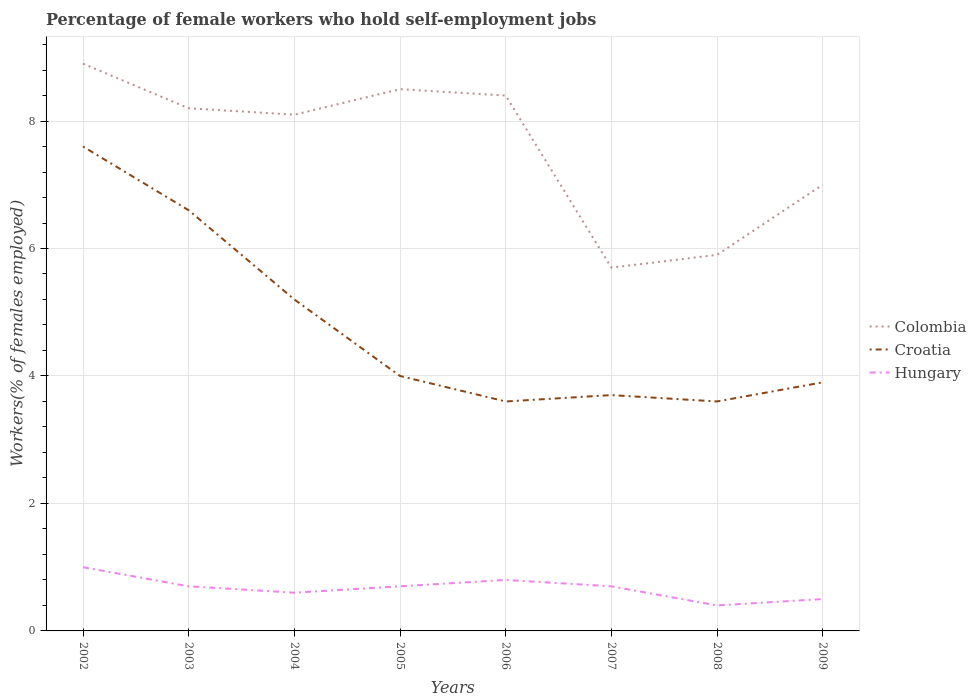How many different coloured lines are there?
Your answer should be compact. 3. Across all years, what is the maximum percentage of self-employed female workers in Hungary?
Your answer should be very brief. 0.4. What is the total percentage of self-employed female workers in Croatia in the graph?
Ensure brevity in your answer.  0.4. What is the difference between the highest and the second highest percentage of self-employed female workers in Colombia?
Offer a very short reply. 3.2. Is the percentage of self-employed female workers in Colombia strictly greater than the percentage of self-employed female workers in Hungary over the years?
Offer a very short reply. No. How many years are there in the graph?
Provide a succinct answer. 8. What is the difference between two consecutive major ticks on the Y-axis?
Give a very brief answer. 2. Are the values on the major ticks of Y-axis written in scientific E-notation?
Give a very brief answer. No. Does the graph contain any zero values?
Your answer should be very brief. No. Where does the legend appear in the graph?
Ensure brevity in your answer.  Center right. How many legend labels are there?
Keep it short and to the point. 3. How are the legend labels stacked?
Provide a succinct answer. Vertical. What is the title of the graph?
Keep it short and to the point. Percentage of female workers who hold self-employment jobs. What is the label or title of the X-axis?
Your answer should be compact. Years. What is the label or title of the Y-axis?
Give a very brief answer. Workers(% of females employed). What is the Workers(% of females employed) in Colombia in 2002?
Provide a short and direct response. 8.9. What is the Workers(% of females employed) in Croatia in 2002?
Make the answer very short. 7.6. What is the Workers(% of females employed) in Hungary in 2002?
Your answer should be compact. 1. What is the Workers(% of females employed) in Colombia in 2003?
Your answer should be compact. 8.2. What is the Workers(% of females employed) in Croatia in 2003?
Make the answer very short. 6.6. What is the Workers(% of females employed) of Hungary in 2003?
Ensure brevity in your answer.  0.7. What is the Workers(% of females employed) of Colombia in 2004?
Your response must be concise. 8.1. What is the Workers(% of females employed) of Croatia in 2004?
Give a very brief answer. 5.2. What is the Workers(% of females employed) of Hungary in 2004?
Your response must be concise. 0.6. What is the Workers(% of females employed) in Colombia in 2005?
Keep it short and to the point. 8.5. What is the Workers(% of females employed) in Hungary in 2005?
Offer a very short reply. 0.7. What is the Workers(% of females employed) in Colombia in 2006?
Keep it short and to the point. 8.4. What is the Workers(% of females employed) in Croatia in 2006?
Keep it short and to the point. 3.6. What is the Workers(% of females employed) in Hungary in 2006?
Provide a short and direct response. 0.8. What is the Workers(% of females employed) of Colombia in 2007?
Provide a succinct answer. 5.7. What is the Workers(% of females employed) in Croatia in 2007?
Provide a succinct answer. 3.7. What is the Workers(% of females employed) in Hungary in 2007?
Your answer should be very brief. 0.7. What is the Workers(% of females employed) in Colombia in 2008?
Provide a short and direct response. 5.9. What is the Workers(% of females employed) in Croatia in 2008?
Your answer should be compact. 3.6. What is the Workers(% of females employed) in Hungary in 2008?
Give a very brief answer. 0.4. What is the Workers(% of females employed) of Croatia in 2009?
Ensure brevity in your answer.  3.9. Across all years, what is the maximum Workers(% of females employed) of Colombia?
Provide a succinct answer. 8.9. Across all years, what is the maximum Workers(% of females employed) in Croatia?
Ensure brevity in your answer.  7.6. Across all years, what is the minimum Workers(% of females employed) in Colombia?
Your response must be concise. 5.7. Across all years, what is the minimum Workers(% of females employed) of Croatia?
Your response must be concise. 3.6. Across all years, what is the minimum Workers(% of females employed) in Hungary?
Provide a succinct answer. 0.4. What is the total Workers(% of females employed) in Colombia in the graph?
Keep it short and to the point. 60.7. What is the total Workers(% of females employed) of Croatia in the graph?
Offer a terse response. 38.2. What is the total Workers(% of females employed) of Hungary in the graph?
Ensure brevity in your answer.  5.4. What is the difference between the Workers(% of females employed) in Colombia in 2002 and that in 2003?
Your answer should be very brief. 0.7. What is the difference between the Workers(% of females employed) in Croatia in 2002 and that in 2003?
Keep it short and to the point. 1. What is the difference between the Workers(% of females employed) in Hungary in 2002 and that in 2003?
Your answer should be compact. 0.3. What is the difference between the Workers(% of females employed) in Colombia in 2002 and that in 2004?
Provide a short and direct response. 0.8. What is the difference between the Workers(% of females employed) of Colombia in 2002 and that in 2005?
Offer a terse response. 0.4. What is the difference between the Workers(% of females employed) of Colombia in 2002 and that in 2006?
Your answer should be compact. 0.5. What is the difference between the Workers(% of females employed) in Croatia in 2002 and that in 2006?
Your answer should be compact. 4. What is the difference between the Workers(% of females employed) of Hungary in 2002 and that in 2006?
Provide a short and direct response. 0.2. What is the difference between the Workers(% of females employed) in Colombia in 2002 and that in 2007?
Give a very brief answer. 3.2. What is the difference between the Workers(% of females employed) of Hungary in 2002 and that in 2009?
Offer a terse response. 0.5. What is the difference between the Workers(% of females employed) in Colombia in 2003 and that in 2007?
Offer a terse response. 2.5. What is the difference between the Workers(% of females employed) of Hungary in 2003 and that in 2007?
Make the answer very short. 0. What is the difference between the Workers(% of females employed) in Colombia in 2003 and that in 2008?
Keep it short and to the point. 2.3. What is the difference between the Workers(% of females employed) of Hungary in 2003 and that in 2009?
Ensure brevity in your answer.  0.2. What is the difference between the Workers(% of females employed) in Colombia in 2004 and that in 2005?
Make the answer very short. -0.4. What is the difference between the Workers(% of females employed) in Croatia in 2004 and that in 2005?
Offer a terse response. 1.2. What is the difference between the Workers(% of females employed) of Hungary in 2004 and that in 2005?
Ensure brevity in your answer.  -0.1. What is the difference between the Workers(% of females employed) of Colombia in 2004 and that in 2006?
Provide a succinct answer. -0.3. What is the difference between the Workers(% of females employed) of Colombia in 2004 and that in 2007?
Ensure brevity in your answer.  2.4. What is the difference between the Workers(% of females employed) of Hungary in 2004 and that in 2008?
Offer a terse response. 0.2. What is the difference between the Workers(% of females employed) in Croatia in 2005 and that in 2007?
Give a very brief answer. 0.3. What is the difference between the Workers(% of females employed) of Hungary in 2005 and that in 2007?
Offer a very short reply. 0. What is the difference between the Workers(% of females employed) in Croatia in 2005 and that in 2008?
Ensure brevity in your answer.  0.4. What is the difference between the Workers(% of females employed) in Croatia in 2005 and that in 2009?
Provide a short and direct response. 0.1. What is the difference between the Workers(% of females employed) in Hungary in 2005 and that in 2009?
Your answer should be very brief. 0.2. What is the difference between the Workers(% of females employed) of Colombia in 2006 and that in 2007?
Make the answer very short. 2.7. What is the difference between the Workers(% of females employed) in Croatia in 2006 and that in 2007?
Your answer should be compact. -0.1. What is the difference between the Workers(% of females employed) in Hungary in 2006 and that in 2007?
Provide a short and direct response. 0.1. What is the difference between the Workers(% of females employed) of Colombia in 2006 and that in 2008?
Your response must be concise. 2.5. What is the difference between the Workers(% of females employed) of Croatia in 2006 and that in 2008?
Your answer should be very brief. 0. What is the difference between the Workers(% of females employed) in Hungary in 2006 and that in 2008?
Offer a terse response. 0.4. What is the difference between the Workers(% of females employed) in Croatia in 2006 and that in 2009?
Offer a terse response. -0.3. What is the difference between the Workers(% of females employed) in Colombia in 2007 and that in 2009?
Give a very brief answer. -1.3. What is the difference between the Workers(% of females employed) of Croatia in 2007 and that in 2009?
Ensure brevity in your answer.  -0.2. What is the difference between the Workers(% of females employed) of Colombia in 2002 and the Workers(% of females employed) of Hungary in 2003?
Keep it short and to the point. 8.2. What is the difference between the Workers(% of females employed) of Colombia in 2002 and the Workers(% of females employed) of Croatia in 2004?
Ensure brevity in your answer.  3.7. What is the difference between the Workers(% of females employed) in Croatia in 2002 and the Workers(% of females employed) in Hungary in 2004?
Offer a terse response. 7. What is the difference between the Workers(% of females employed) in Colombia in 2002 and the Workers(% of females employed) in Hungary in 2005?
Ensure brevity in your answer.  8.2. What is the difference between the Workers(% of females employed) in Colombia in 2002 and the Workers(% of females employed) in Hungary in 2006?
Provide a short and direct response. 8.1. What is the difference between the Workers(% of females employed) in Colombia in 2002 and the Workers(% of females employed) in Croatia in 2007?
Give a very brief answer. 5.2. What is the difference between the Workers(% of females employed) in Colombia in 2002 and the Workers(% of females employed) in Hungary in 2007?
Provide a short and direct response. 8.2. What is the difference between the Workers(% of females employed) in Croatia in 2003 and the Workers(% of females employed) in Hungary in 2004?
Your answer should be compact. 6. What is the difference between the Workers(% of females employed) of Croatia in 2003 and the Workers(% of females employed) of Hungary in 2005?
Your answer should be compact. 5.9. What is the difference between the Workers(% of females employed) in Colombia in 2003 and the Workers(% of females employed) in Croatia in 2006?
Your answer should be very brief. 4.6. What is the difference between the Workers(% of females employed) of Colombia in 2003 and the Workers(% of females employed) of Hungary in 2006?
Your answer should be very brief. 7.4. What is the difference between the Workers(% of females employed) in Colombia in 2003 and the Workers(% of females employed) in Croatia in 2007?
Your answer should be very brief. 4.5. What is the difference between the Workers(% of females employed) of Colombia in 2003 and the Workers(% of females employed) of Croatia in 2009?
Make the answer very short. 4.3. What is the difference between the Workers(% of females employed) in Colombia in 2003 and the Workers(% of females employed) in Hungary in 2009?
Your answer should be very brief. 7.7. What is the difference between the Workers(% of females employed) of Croatia in 2003 and the Workers(% of females employed) of Hungary in 2009?
Give a very brief answer. 6.1. What is the difference between the Workers(% of females employed) of Colombia in 2004 and the Workers(% of females employed) of Croatia in 2005?
Ensure brevity in your answer.  4.1. What is the difference between the Workers(% of females employed) of Colombia in 2004 and the Workers(% of females employed) of Hungary in 2005?
Your answer should be compact. 7.4. What is the difference between the Workers(% of females employed) of Croatia in 2004 and the Workers(% of females employed) of Hungary in 2005?
Ensure brevity in your answer.  4.5. What is the difference between the Workers(% of females employed) of Colombia in 2004 and the Workers(% of females employed) of Hungary in 2006?
Provide a short and direct response. 7.3. What is the difference between the Workers(% of females employed) in Croatia in 2004 and the Workers(% of females employed) in Hungary in 2006?
Keep it short and to the point. 4.4. What is the difference between the Workers(% of females employed) in Croatia in 2004 and the Workers(% of females employed) in Hungary in 2007?
Provide a succinct answer. 4.5. What is the difference between the Workers(% of females employed) in Colombia in 2004 and the Workers(% of females employed) in Croatia in 2008?
Ensure brevity in your answer.  4.5. What is the difference between the Workers(% of females employed) of Croatia in 2004 and the Workers(% of females employed) of Hungary in 2009?
Give a very brief answer. 4.7. What is the difference between the Workers(% of females employed) in Colombia in 2005 and the Workers(% of females employed) in Croatia in 2006?
Provide a short and direct response. 4.9. What is the difference between the Workers(% of females employed) of Croatia in 2005 and the Workers(% of females employed) of Hungary in 2006?
Keep it short and to the point. 3.2. What is the difference between the Workers(% of females employed) of Croatia in 2005 and the Workers(% of females employed) of Hungary in 2008?
Your answer should be compact. 3.6. What is the difference between the Workers(% of females employed) of Colombia in 2005 and the Workers(% of females employed) of Hungary in 2009?
Keep it short and to the point. 8. What is the difference between the Workers(% of females employed) of Croatia in 2005 and the Workers(% of females employed) of Hungary in 2009?
Offer a terse response. 3.5. What is the difference between the Workers(% of females employed) of Colombia in 2006 and the Workers(% of females employed) of Hungary in 2007?
Ensure brevity in your answer.  7.7. What is the difference between the Workers(% of females employed) of Croatia in 2006 and the Workers(% of females employed) of Hungary in 2007?
Offer a terse response. 2.9. What is the difference between the Workers(% of females employed) in Colombia in 2006 and the Workers(% of females employed) in Croatia in 2008?
Make the answer very short. 4.8. What is the difference between the Workers(% of females employed) of Colombia in 2006 and the Workers(% of females employed) of Croatia in 2009?
Provide a short and direct response. 4.5. What is the difference between the Workers(% of females employed) of Colombia in 2007 and the Workers(% of females employed) of Croatia in 2008?
Provide a succinct answer. 2.1. What is the difference between the Workers(% of females employed) of Croatia in 2007 and the Workers(% of females employed) of Hungary in 2008?
Give a very brief answer. 3.3. What is the difference between the Workers(% of females employed) in Colombia in 2007 and the Workers(% of females employed) in Hungary in 2009?
Give a very brief answer. 5.2. What is the difference between the Workers(% of females employed) of Colombia in 2008 and the Workers(% of females employed) of Croatia in 2009?
Your answer should be compact. 2. What is the difference between the Workers(% of females employed) in Croatia in 2008 and the Workers(% of females employed) in Hungary in 2009?
Make the answer very short. 3.1. What is the average Workers(% of females employed) in Colombia per year?
Give a very brief answer. 7.59. What is the average Workers(% of females employed) of Croatia per year?
Your response must be concise. 4.78. What is the average Workers(% of females employed) in Hungary per year?
Provide a succinct answer. 0.68. In the year 2002, what is the difference between the Workers(% of females employed) in Colombia and Workers(% of females employed) in Hungary?
Your response must be concise. 7.9. In the year 2002, what is the difference between the Workers(% of females employed) of Croatia and Workers(% of females employed) of Hungary?
Provide a short and direct response. 6.6. In the year 2003, what is the difference between the Workers(% of females employed) in Colombia and Workers(% of females employed) in Hungary?
Provide a succinct answer. 7.5. In the year 2004, what is the difference between the Workers(% of females employed) of Colombia and Workers(% of females employed) of Croatia?
Your answer should be compact. 2.9. In the year 2004, what is the difference between the Workers(% of females employed) of Colombia and Workers(% of females employed) of Hungary?
Keep it short and to the point. 7.5. In the year 2005, what is the difference between the Workers(% of females employed) of Colombia and Workers(% of females employed) of Croatia?
Provide a short and direct response. 4.5. In the year 2005, what is the difference between the Workers(% of females employed) in Croatia and Workers(% of females employed) in Hungary?
Keep it short and to the point. 3.3. In the year 2006, what is the difference between the Workers(% of females employed) of Colombia and Workers(% of females employed) of Croatia?
Give a very brief answer. 4.8. In the year 2006, what is the difference between the Workers(% of females employed) of Colombia and Workers(% of females employed) of Hungary?
Provide a short and direct response. 7.6. In the year 2006, what is the difference between the Workers(% of females employed) of Croatia and Workers(% of females employed) of Hungary?
Offer a terse response. 2.8. In the year 2007, what is the difference between the Workers(% of females employed) of Colombia and Workers(% of females employed) of Croatia?
Provide a succinct answer. 2. In the year 2007, what is the difference between the Workers(% of females employed) of Croatia and Workers(% of females employed) of Hungary?
Make the answer very short. 3. In the year 2008, what is the difference between the Workers(% of females employed) of Colombia and Workers(% of females employed) of Croatia?
Make the answer very short. 2.3. In the year 2008, what is the difference between the Workers(% of females employed) in Colombia and Workers(% of females employed) in Hungary?
Provide a short and direct response. 5.5. In the year 2009, what is the difference between the Workers(% of females employed) in Colombia and Workers(% of females employed) in Hungary?
Offer a terse response. 6.5. In the year 2009, what is the difference between the Workers(% of females employed) of Croatia and Workers(% of females employed) of Hungary?
Give a very brief answer. 3.4. What is the ratio of the Workers(% of females employed) in Colombia in 2002 to that in 2003?
Your response must be concise. 1.09. What is the ratio of the Workers(% of females employed) in Croatia in 2002 to that in 2003?
Your answer should be very brief. 1.15. What is the ratio of the Workers(% of females employed) in Hungary in 2002 to that in 2003?
Your response must be concise. 1.43. What is the ratio of the Workers(% of females employed) in Colombia in 2002 to that in 2004?
Your answer should be compact. 1.1. What is the ratio of the Workers(% of females employed) of Croatia in 2002 to that in 2004?
Your answer should be very brief. 1.46. What is the ratio of the Workers(% of females employed) of Hungary in 2002 to that in 2004?
Give a very brief answer. 1.67. What is the ratio of the Workers(% of females employed) of Colombia in 2002 to that in 2005?
Give a very brief answer. 1.05. What is the ratio of the Workers(% of females employed) in Croatia in 2002 to that in 2005?
Your answer should be very brief. 1.9. What is the ratio of the Workers(% of females employed) of Hungary in 2002 to that in 2005?
Your answer should be compact. 1.43. What is the ratio of the Workers(% of females employed) in Colombia in 2002 to that in 2006?
Provide a short and direct response. 1.06. What is the ratio of the Workers(% of females employed) of Croatia in 2002 to that in 2006?
Offer a very short reply. 2.11. What is the ratio of the Workers(% of females employed) in Hungary in 2002 to that in 2006?
Your response must be concise. 1.25. What is the ratio of the Workers(% of females employed) of Colombia in 2002 to that in 2007?
Give a very brief answer. 1.56. What is the ratio of the Workers(% of females employed) of Croatia in 2002 to that in 2007?
Your response must be concise. 2.05. What is the ratio of the Workers(% of females employed) in Hungary in 2002 to that in 2007?
Give a very brief answer. 1.43. What is the ratio of the Workers(% of females employed) in Colombia in 2002 to that in 2008?
Ensure brevity in your answer.  1.51. What is the ratio of the Workers(% of females employed) in Croatia in 2002 to that in 2008?
Keep it short and to the point. 2.11. What is the ratio of the Workers(% of females employed) in Hungary in 2002 to that in 2008?
Give a very brief answer. 2.5. What is the ratio of the Workers(% of females employed) in Colombia in 2002 to that in 2009?
Keep it short and to the point. 1.27. What is the ratio of the Workers(% of females employed) of Croatia in 2002 to that in 2009?
Your response must be concise. 1.95. What is the ratio of the Workers(% of females employed) of Hungary in 2002 to that in 2009?
Make the answer very short. 2. What is the ratio of the Workers(% of females employed) of Colombia in 2003 to that in 2004?
Give a very brief answer. 1.01. What is the ratio of the Workers(% of females employed) in Croatia in 2003 to that in 2004?
Your answer should be compact. 1.27. What is the ratio of the Workers(% of females employed) of Colombia in 2003 to that in 2005?
Offer a terse response. 0.96. What is the ratio of the Workers(% of females employed) in Croatia in 2003 to that in 2005?
Your answer should be very brief. 1.65. What is the ratio of the Workers(% of females employed) of Hungary in 2003 to that in 2005?
Offer a terse response. 1. What is the ratio of the Workers(% of females employed) of Colombia in 2003 to that in 2006?
Provide a short and direct response. 0.98. What is the ratio of the Workers(% of females employed) of Croatia in 2003 to that in 2006?
Ensure brevity in your answer.  1.83. What is the ratio of the Workers(% of females employed) in Hungary in 2003 to that in 2006?
Your response must be concise. 0.88. What is the ratio of the Workers(% of females employed) in Colombia in 2003 to that in 2007?
Make the answer very short. 1.44. What is the ratio of the Workers(% of females employed) of Croatia in 2003 to that in 2007?
Offer a terse response. 1.78. What is the ratio of the Workers(% of females employed) in Colombia in 2003 to that in 2008?
Offer a very short reply. 1.39. What is the ratio of the Workers(% of females employed) in Croatia in 2003 to that in 2008?
Your response must be concise. 1.83. What is the ratio of the Workers(% of females employed) of Colombia in 2003 to that in 2009?
Your response must be concise. 1.17. What is the ratio of the Workers(% of females employed) in Croatia in 2003 to that in 2009?
Keep it short and to the point. 1.69. What is the ratio of the Workers(% of females employed) of Colombia in 2004 to that in 2005?
Your answer should be compact. 0.95. What is the ratio of the Workers(% of females employed) of Croatia in 2004 to that in 2006?
Give a very brief answer. 1.44. What is the ratio of the Workers(% of females employed) of Hungary in 2004 to that in 2006?
Your answer should be very brief. 0.75. What is the ratio of the Workers(% of females employed) in Colombia in 2004 to that in 2007?
Offer a terse response. 1.42. What is the ratio of the Workers(% of females employed) of Croatia in 2004 to that in 2007?
Provide a succinct answer. 1.41. What is the ratio of the Workers(% of females employed) of Colombia in 2004 to that in 2008?
Ensure brevity in your answer.  1.37. What is the ratio of the Workers(% of females employed) of Croatia in 2004 to that in 2008?
Give a very brief answer. 1.44. What is the ratio of the Workers(% of females employed) in Colombia in 2004 to that in 2009?
Provide a short and direct response. 1.16. What is the ratio of the Workers(% of females employed) of Colombia in 2005 to that in 2006?
Offer a very short reply. 1.01. What is the ratio of the Workers(% of females employed) in Croatia in 2005 to that in 2006?
Offer a very short reply. 1.11. What is the ratio of the Workers(% of females employed) in Hungary in 2005 to that in 2006?
Make the answer very short. 0.88. What is the ratio of the Workers(% of females employed) in Colombia in 2005 to that in 2007?
Your response must be concise. 1.49. What is the ratio of the Workers(% of females employed) of Croatia in 2005 to that in 2007?
Ensure brevity in your answer.  1.08. What is the ratio of the Workers(% of females employed) in Colombia in 2005 to that in 2008?
Your response must be concise. 1.44. What is the ratio of the Workers(% of females employed) of Hungary in 2005 to that in 2008?
Provide a short and direct response. 1.75. What is the ratio of the Workers(% of females employed) in Colombia in 2005 to that in 2009?
Your answer should be very brief. 1.21. What is the ratio of the Workers(% of females employed) of Croatia in 2005 to that in 2009?
Provide a succinct answer. 1.03. What is the ratio of the Workers(% of females employed) in Colombia in 2006 to that in 2007?
Provide a succinct answer. 1.47. What is the ratio of the Workers(% of females employed) in Croatia in 2006 to that in 2007?
Offer a very short reply. 0.97. What is the ratio of the Workers(% of females employed) of Colombia in 2006 to that in 2008?
Keep it short and to the point. 1.42. What is the ratio of the Workers(% of females employed) in Hungary in 2006 to that in 2008?
Ensure brevity in your answer.  2. What is the ratio of the Workers(% of females employed) of Colombia in 2006 to that in 2009?
Make the answer very short. 1.2. What is the ratio of the Workers(% of females employed) of Croatia in 2006 to that in 2009?
Make the answer very short. 0.92. What is the ratio of the Workers(% of females employed) in Colombia in 2007 to that in 2008?
Provide a succinct answer. 0.97. What is the ratio of the Workers(% of females employed) in Croatia in 2007 to that in 2008?
Offer a very short reply. 1.03. What is the ratio of the Workers(% of females employed) in Colombia in 2007 to that in 2009?
Your answer should be compact. 0.81. What is the ratio of the Workers(% of females employed) in Croatia in 2007 to that in 2009?
Ensure brevity in your answer.  0.95. What is the ratio of the Workers(% of females employed) in Hungary in 2007 to that in 2009?
Your answer should be compact. 1.4. What is the ratio of the Workers(% of females employed) in Colombia in 2008 to that in 2009?
Your answer should be compact. 0.84. What is the ratio of the Workers(% of females employed) of Croatia in 2008 to that in 2009?
Offer a terse response. 0.92. What is the ratio of the Workers(% of females employed) in Hungary in 2008 to that in 2009?
Provide a succinct answer. 0.8. What is the difference between the highest and the second highest Workers(% of females employed) in Croatia?
Your answer should be compact. 1. What is the difference between the highest and the lowest Workers(% of females employed) in Croatia?
Provide a short and direct response. 4. 